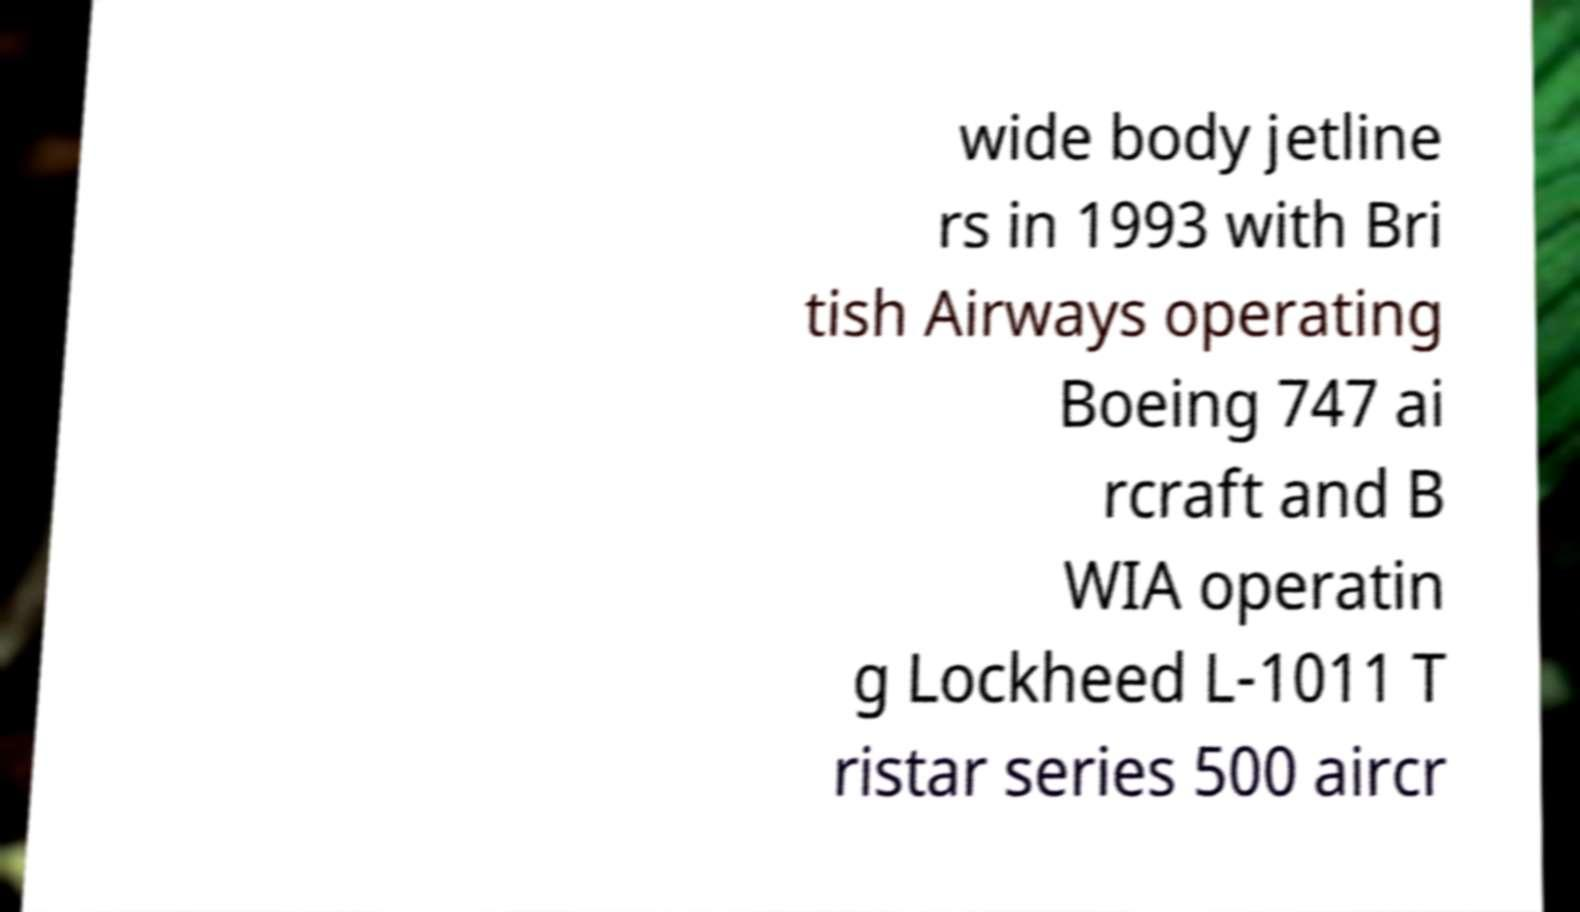Can you read and provide the text displayed in the image?This photo seems to have some interesting text. Can you extract and type it out for me? wide body jetline rs in 1993 with Bri tish Airways operating Boeing 747 ai rcraft and B WIA operatin g Lockheed L-1011 T ristar series 500 aircr 